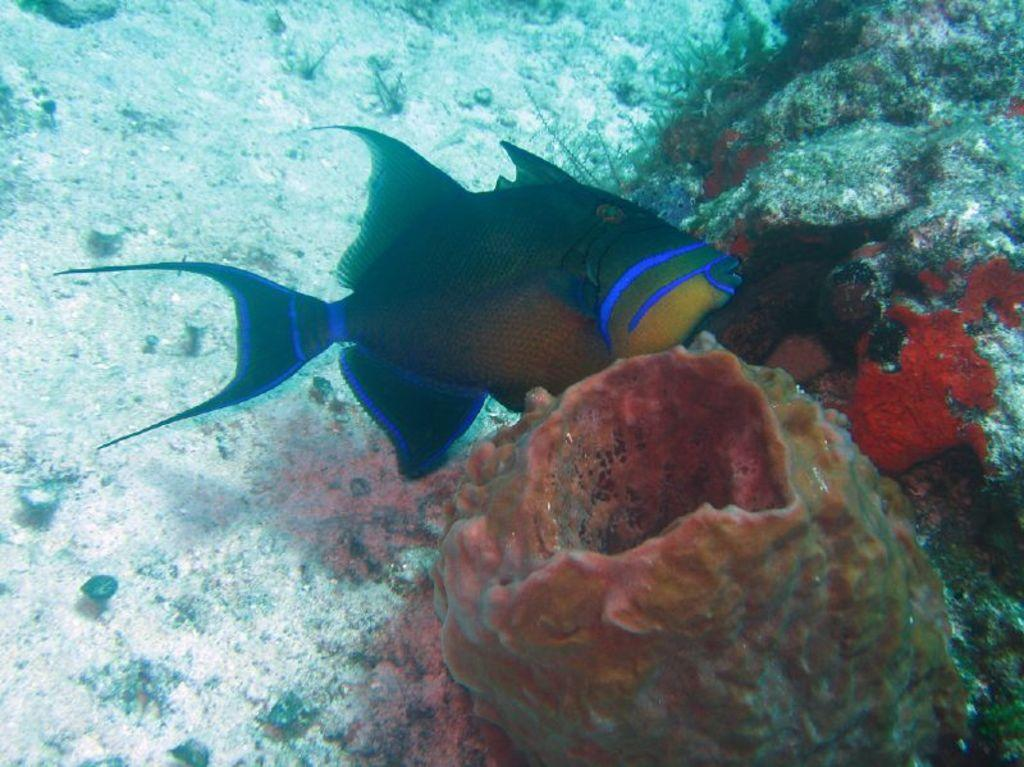What is the main subject of the image? There is a fish in the image. Where is the fish located? The fish is in the water. What type of pain is the fish experiencing in the image? There is no indication of pain in the image; the fish appears to be in its natural environment. 